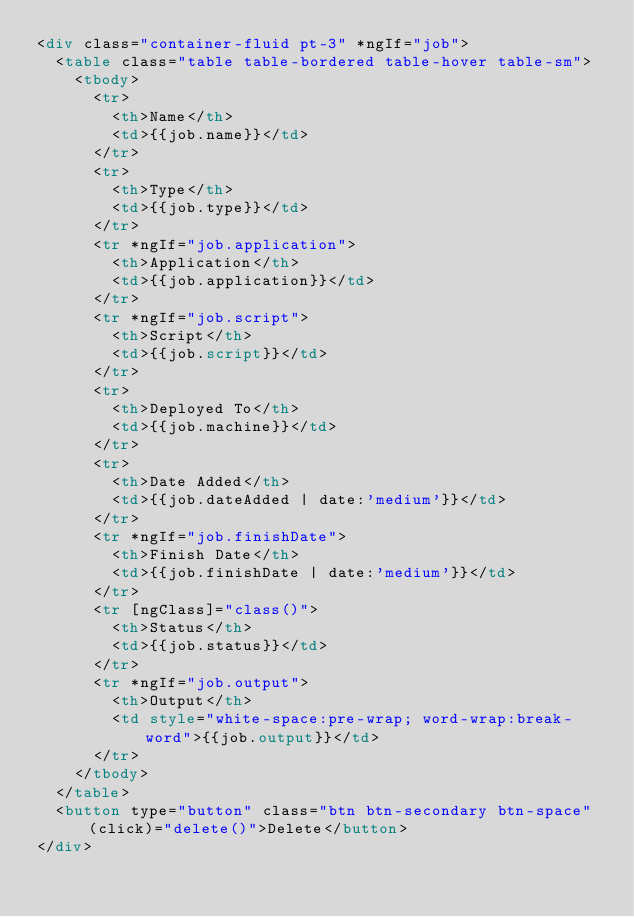Convert code to text. <code><loc_0><loc_0><loc_500><loc_500><_HTML_><div class="container-fluid pt-3" *ngIf="job">
  <table class="table table-bordered table-hover table-sm">
    <tbody>
      <tr>
        <th>Name</th>
        <td>{{job.name}}</td>
      </tr>
      <tr>
        <th>Type</th>
        <td>{{job.type}}</td>
      </tr>
      <tr *ngIf="job.application">
        <th>Application</th>
        <td>{{job.application}}</td>
      </tr>
      <tr *ngIf="job.script">
        <th>Script</th>
        <td>{{job.script}}</td>
      </tr>
      <tr>
        <th>Deployed To</th>
        <td>{{job.machine}}</td>
      </tr>
      <tr>
        <th>Date Added</th>
        <td>{{job.dateAdded | date:'medium'}}</td>
      </tr>
      <tr *ngIf="job.finishDate">
        <th>Finish Date</th>
        <td>{{job.finishDate | date:'medium'}}</td>
      </tr>
      <tr [ngClass]="class()">
        <th>Status</th>
        <td>{{job.status}}</td>
      </tr>
      <tr *ngIf="job.output">
        <th>Output</th>
        <td style="white-space:pre-wrap; word-wrap:break-word">{{job.output}}</td>
      </tr>
    </tbody>
  </table>
  <button type="button" class="btn btn-secondary btn-space" (click)="delete()">Delete</button>
</div></code> 